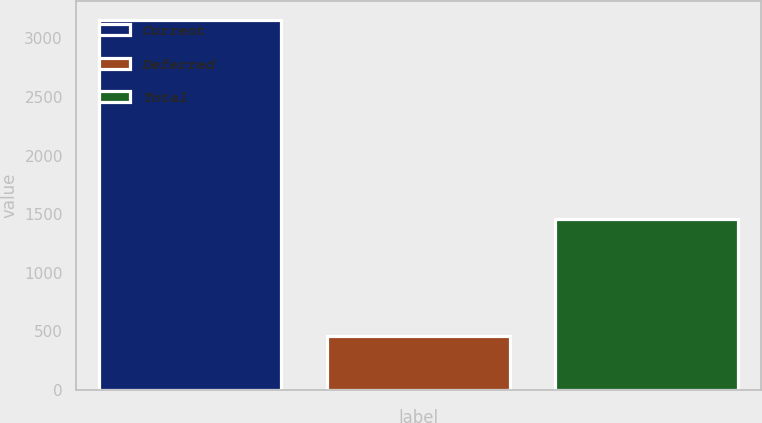Convert chart. <chart><loc_0><loc_0><loc_500><loc_500><bar_chart><fcel>Current<fcel>Deferred<fcel>Total<nl><fcel>3157<fcel>461<fcel>1455<nl></chart> 